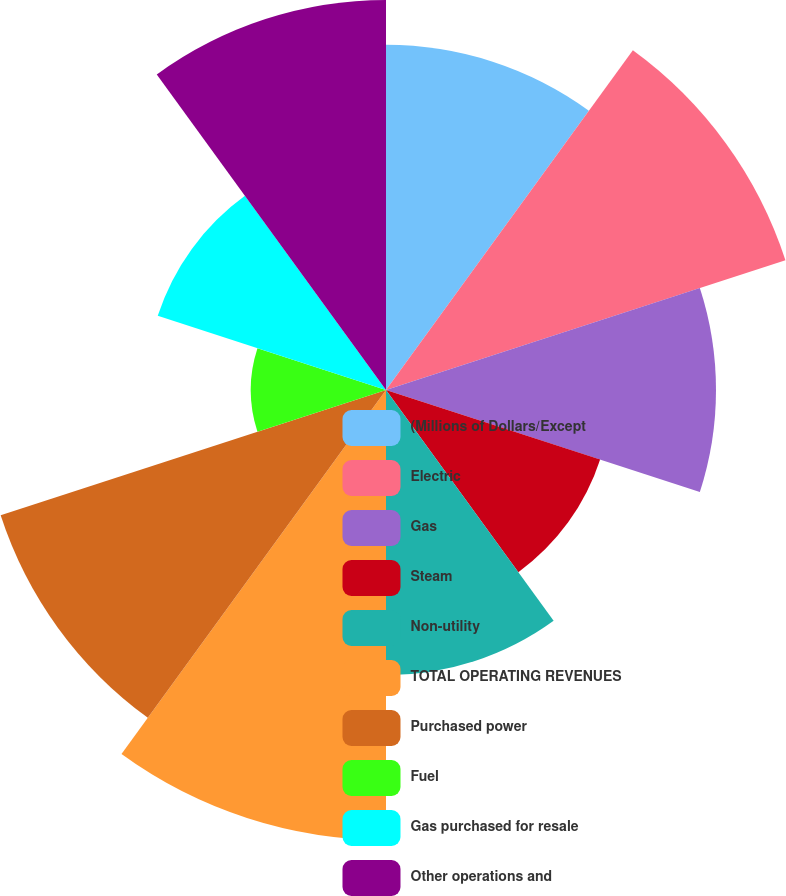Convert chart to OTSL. <chart><loc_0><loc_0><loc_500><loc_500><pie_chart><fcel>(Millions of Dollars/Except<fcel>Electric<fcel>Gas<fcel>Steam<fcel>Non-utility<fcel>TOTAL OPERATING REVENUES<fcel>Purchased power<fcel>Fuel<fcel>Gas purchased for resale<fcel>Other operations and<nl><fcel>10.7%<fcel>13.02%<fcel>10.23%<fcel>6.98%<fcel>8.84%<fcel>13.95%<fcel>12.56%<fcel>4.19%<fcel>7.44%<fcel>12.09%<nl></chart> 